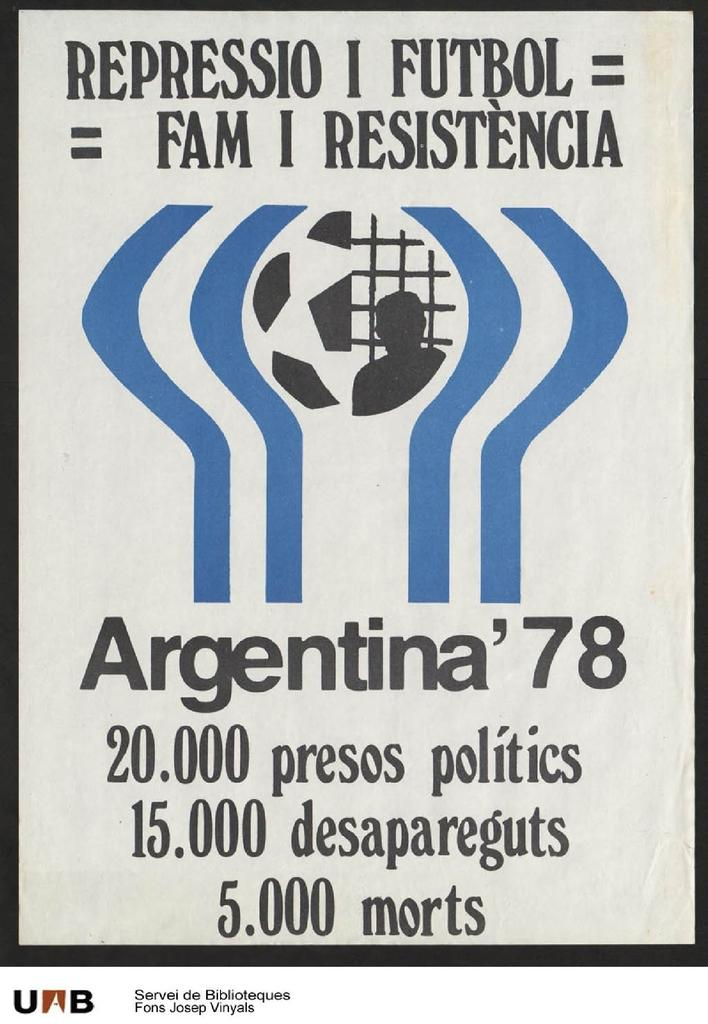<image>
Describe the image concisely. An advertisement has a soccer ball and Argentina 78 shown on it. 